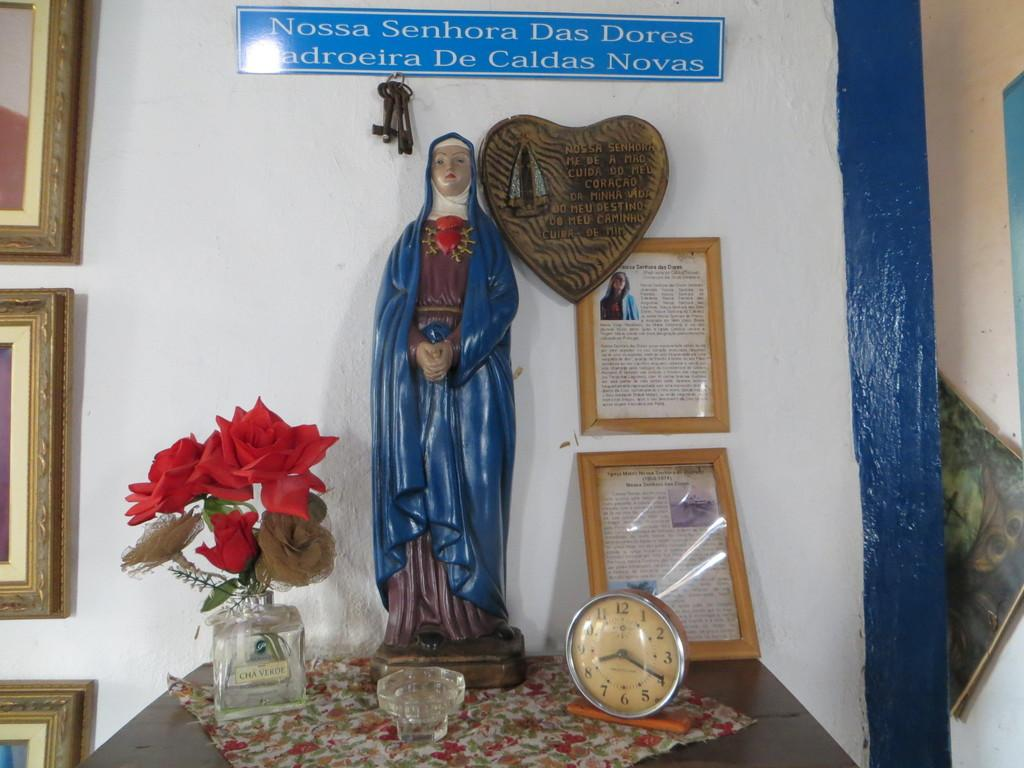<image>
Write a terse but informative summary of the picture. the name Nossa is on the sign above a statue 